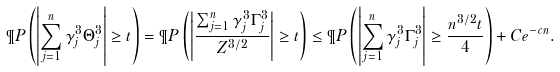<formula> <loc_0><loc_0><loc_500><loc_500>\P P \left ( \left | \sum _ { j = 1 } ^ { n } \gamma _ { j } ^ { 3 } \Theta _ { j } ^ { 3 } \right | \geq t \right ) = \P P \left ( \left | \frac { \sum _ { j = 1 } ^ { n } \gamma _ { j } ^ { 3 } \Gamma _ { j } ^ { 3 } } { Z ^ { 3 / 2 } } \right | \geq t \right ) \leq \P P \left ( \left | \sum _ { j = 1 } ^ { n } \gamma _ { j } ^ { 3 } \Gamma _ { j } ^ { 3 } \right | \geq \frac { n ^ { 3 / 2 } t } { 4 } \right ) + C e ^ { - c n } .</formula> 